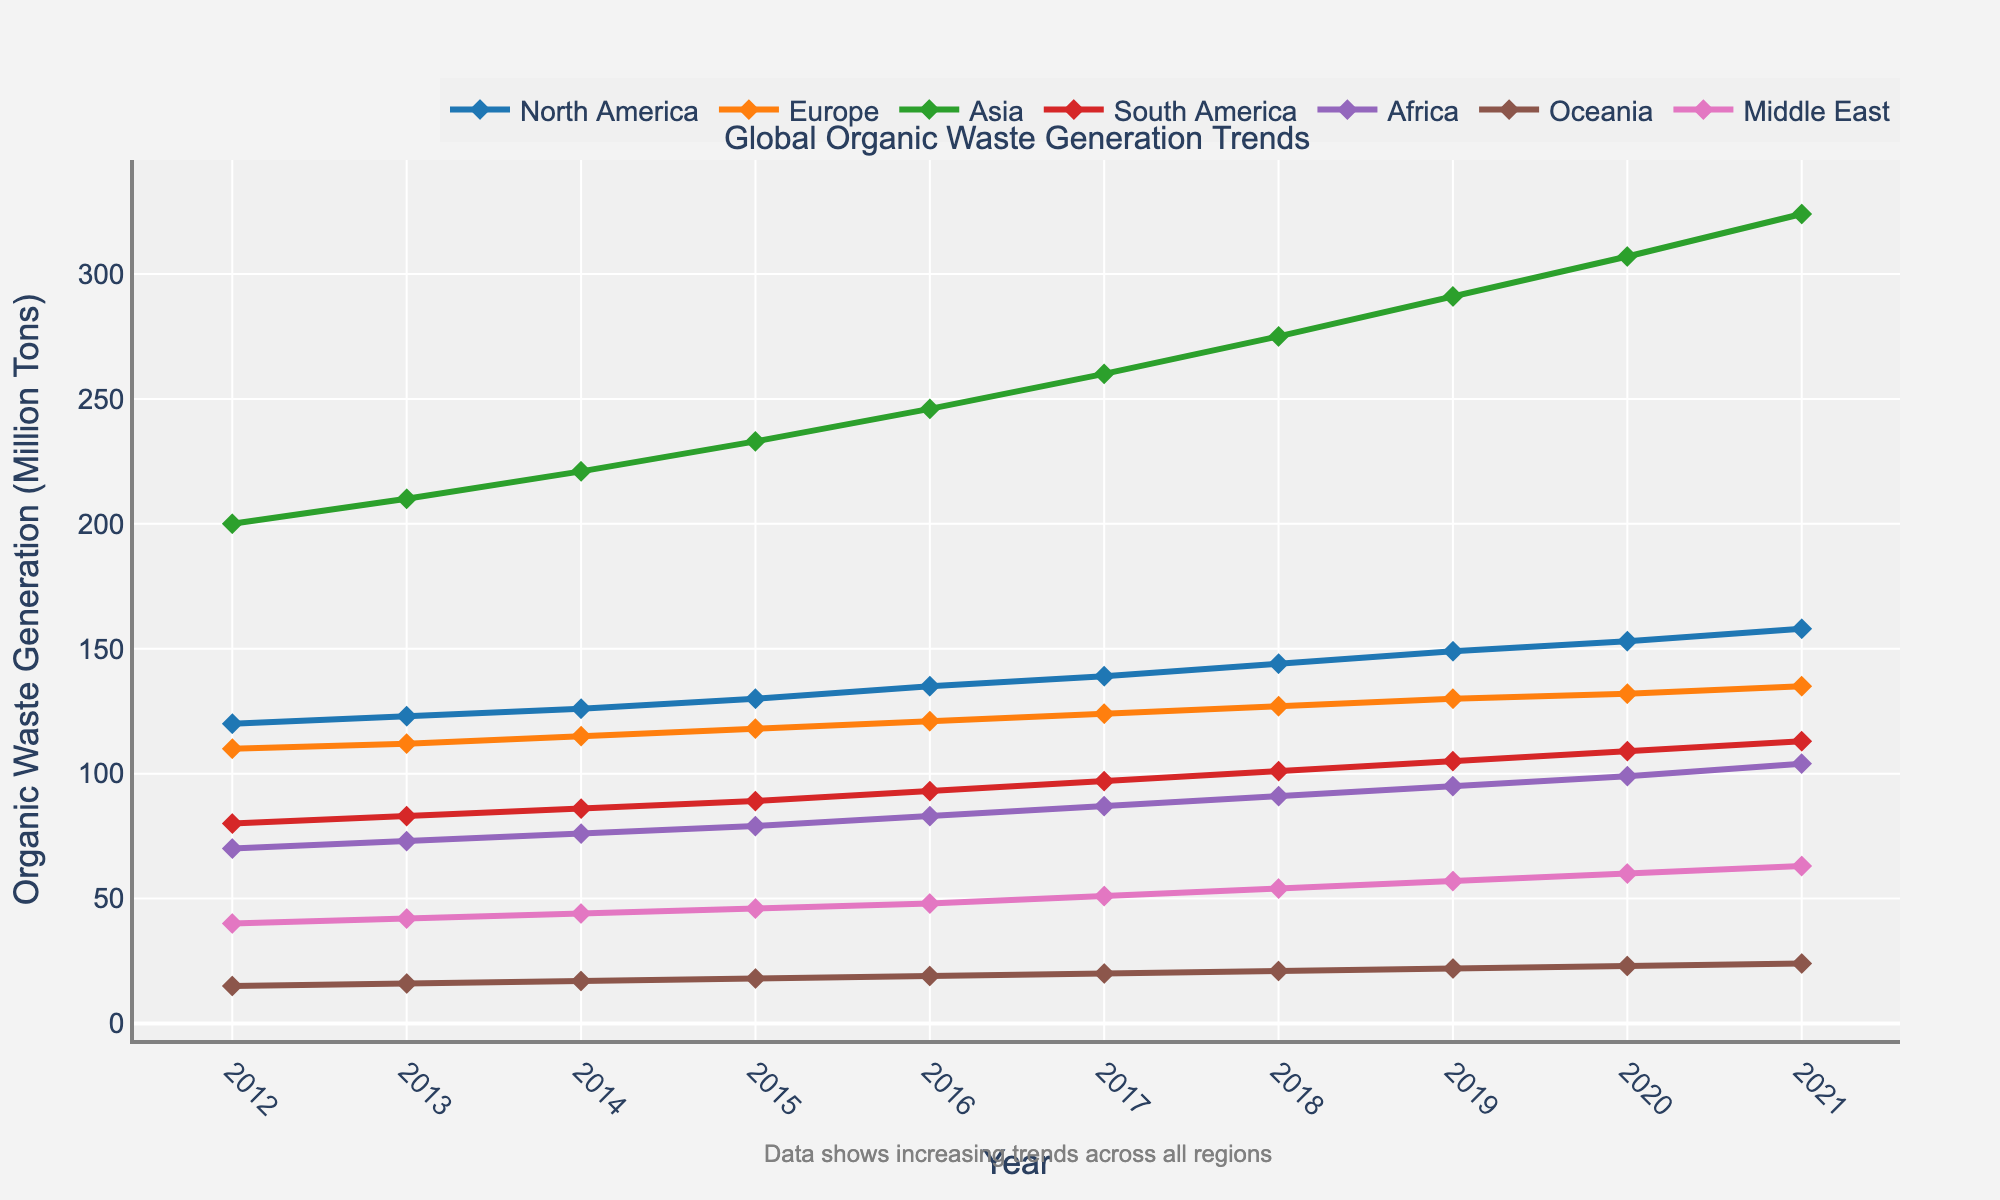Which region has the highest organic waste generation in 2021? The chart shows organic waste generation trends broken down by region. By examining the end points of all lines for the year 2021, the region with the highest marked point is Asia.
Answer: Asia How much did organic waste generation increase in North America from 2012 to 2021? To find the increase, subtract the 2012 value from the 2021 value for North America. The chart shows 120 million tons in 2012 and 158 million tons in 2021, so the increase is 158 - 120.
Answer: 38 million tons Which two regions had the smallest difference in organic waste generation in 2021? Look at the end points of all lines for the year 2021 and compare the values. Africa and South America have values of 104 and 113 million tons respectively, making the difference 113 - 104. This difference (9 million tons) is the smallest compared to differences between other regions.
Answer: Africa and South America What is the average organic waste generation in Europe from 2015 to 2021? To find the average, add the values for Europe from 2015 to 2021 and divide by the number of years. The values are 118, 121, 124, 127, 130, 132, and 135 million tons. Sum these values (118 + 121 + 124 + 127 + 130 + 132 + 135 = 887) and divide by 7 years.
Answer: 126.71 million tons Between which pair of years did Asia experience the greatest increase in organic waste generation? Examine the vertical distance between consecutive data points for Asia. The largest increase is between 2019 and 2020, where the value jumps from 291 to 307 million tons, an increase of 16 million tons.
Answer: 2019 and 2020 What was the approximate total global organic waste generation in 2021? Sum the values for all regions in 2021. The values are 158, 135, 324, 113, 104, 24, and 63 million tons. Total is 158 + 135 + 324 + 113 + 104 + 24 + 63 = 921 million tons.
Answer: 921 million tons Which region showed the most consistent increase in organic waste generation over the decade? Check the smoothness and steadiness of the lines. Europe shows a relatively smooth and consistent increase without any noticeable fluctuations.
Answer: Europe 